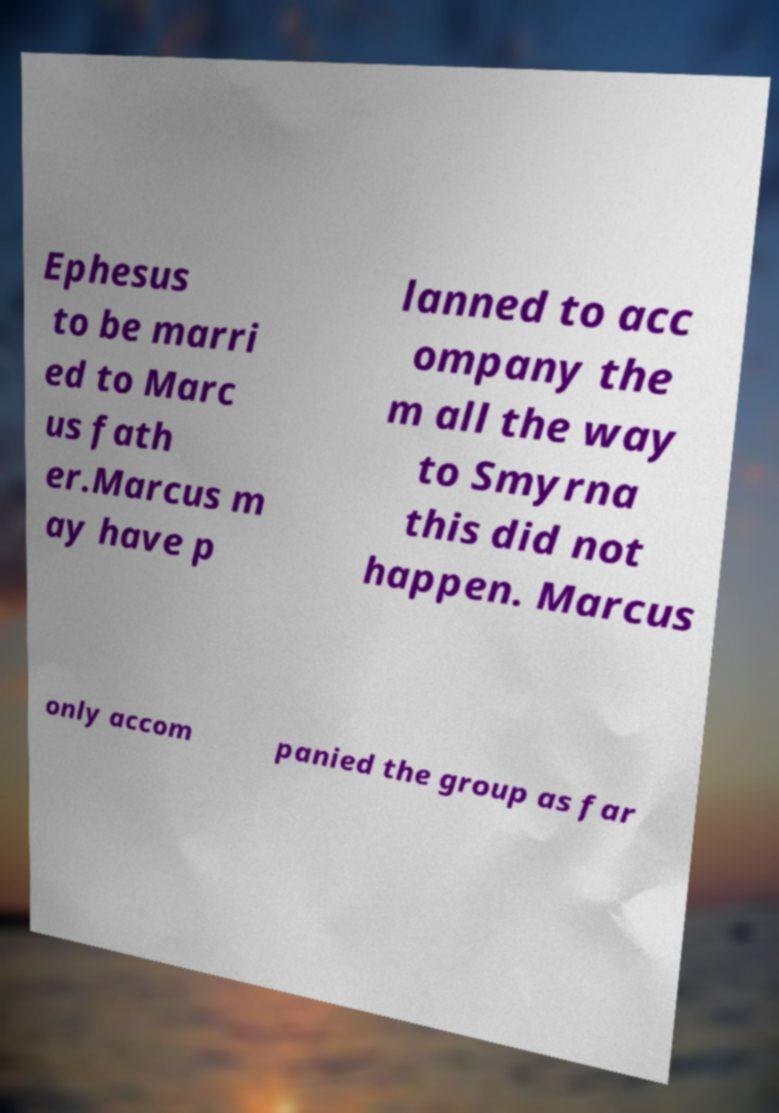Could you assist in decoding the text presented in this image and type it out clearly? Ephesus to be marri ed to Marc us fath er.Marcus m ay have p lanned to acc ompany the m all the way to Smyrna this did not happen. Marcus only accom panied the group as far 